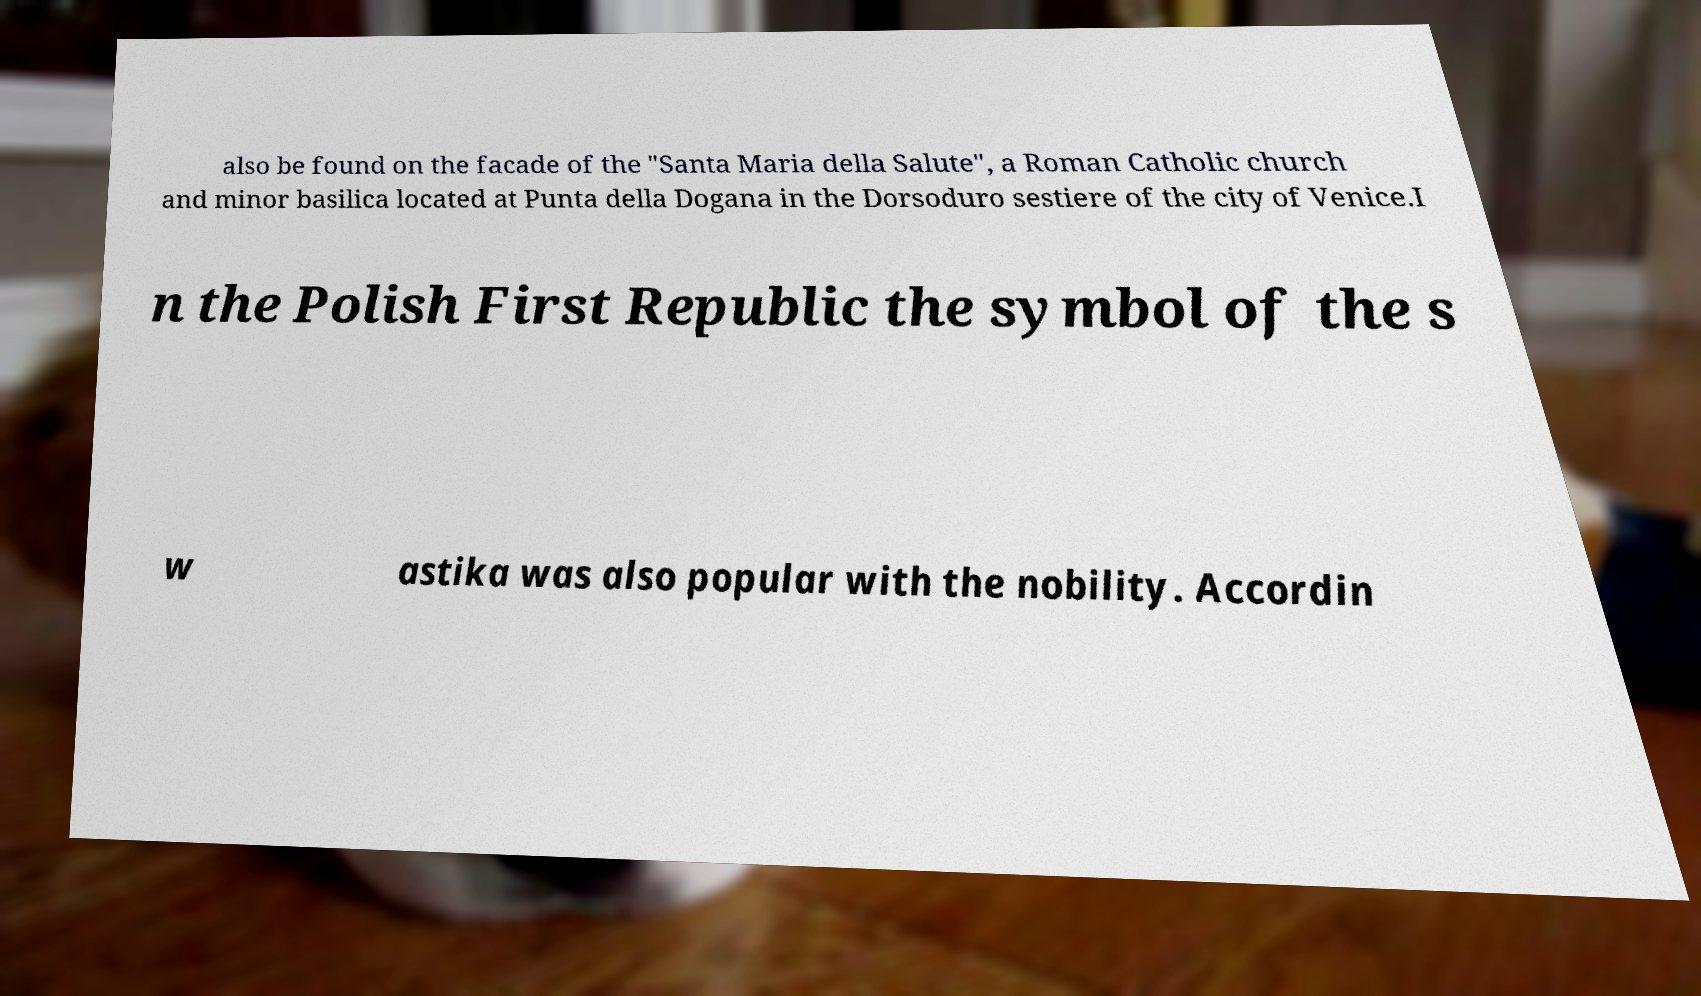I need the written content from this picture converted into text. Can you do that? also be found on the facade of the "Santa Maria della Salute", a Roman Catholic church and minor basilica located at Punta della Dogana in the Dorsoduro sestiere of the city of Venice.I n the Polish First Republic the symbol of the s w astika was also popular with the nobility. Accordin 